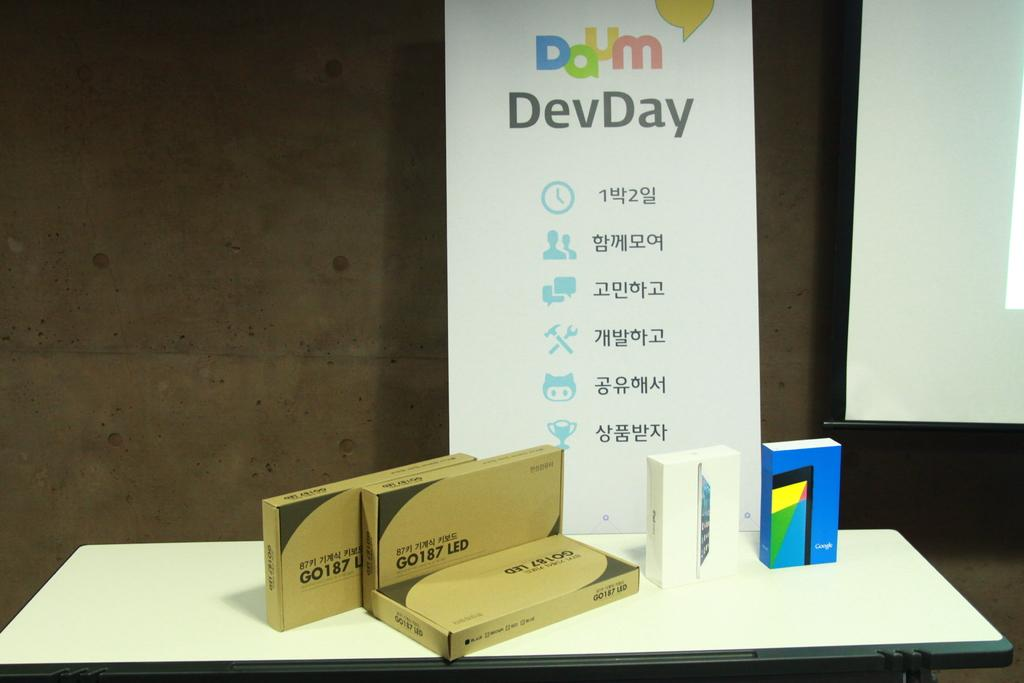Provide a one-sentence caption for the provided image. A sign for Daum DevDay stands on a table behind boxes of GO 187 LED and a Google phone box. 